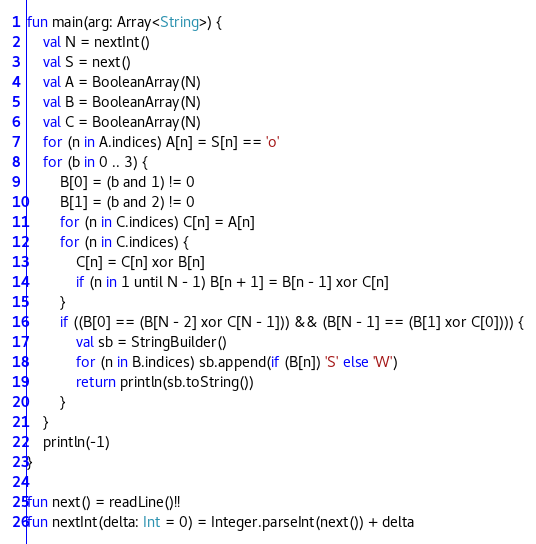<code> <loc_0><loc_0><loc_500><loc_500><_Kotlin_>fun main(arg: Array<String>) {
    val N = nextInt()
    val S = next()
    val A = BooleanArray(N)
    val B = BooleanArray(N)
    val C = BooleanArray(N)
    for (n in A.indices) A[n] = S[n] == 'o'
    for (b in 0 .. 3) {
        B[0] = (b and 1) != 0
        B[1] = (b and 2) != 0
        for (n in C.indices) C[n] = A[n]
        for (n in C.indices) {
            C[n] = C[n] xor B[n]
            if (n in 1 until N - 1) B[n + 1] = B[n - 1] xor C[n]
        }
        if ((B[0] == (B[N - 2] xor C[N - 1])) && (B[N - 1] == (B[1] xor C[0]))) {
            val sb = StringBuilder()
            for (n in B.indices) sb.append(if (B[n]) 'S' else 'W')
            return println(sb.toString())
        }
    }
    println(-1)
}

fun next() = readLine()!!
fun nextInt(delta: Int = 0) = Integer.parseInt(next()) + delta
</code> 